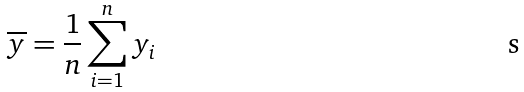Convert formula to latex. <formula><loc_0><loc_0><loc_500><loc_500>\overline { y } = \frac { 1 } { n } \sum _ { i = 1 } ^ { n } y _ { i }</formula> 